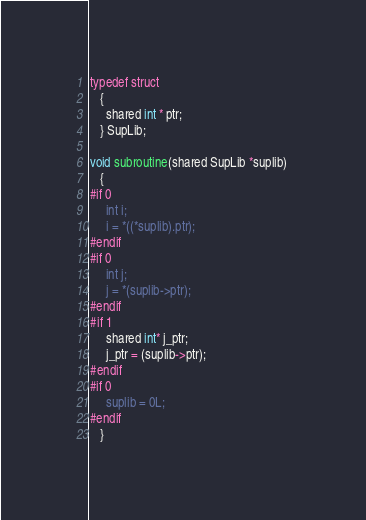Convert code to text. <code><loc_0><loc_0><loc_500><loc_500><_C_>typedef struct 
   {
     shared int * ptr;
   } SupLib;

void subroutine(shared SupLib *suplib) 
   {
#if 0
     int i;
     i = *((*suplib).ptr);
#endif
#if 0
     int j;
     j = *(suplib->ptr);
#endif
#if 1
     shared int* j_ptr;
     j_ptr = (suplib->ptr);
#endif
#if 0
     suplib = 0L;
#endif
   }
</code> 